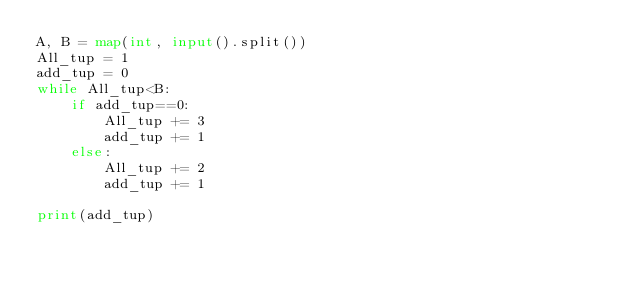<code> <loc_0><loc_0><loc_500><loc_500><_Python_>A, B = map(int, input().split())
All_tup = 1
add_tup = 0
while All_tup<B:
    if add_tup==0:
        All_tup += 3
        add_tup += 1
    else:
        All_tup += 2
        add_tup += 1

print(add_tup)</code> 